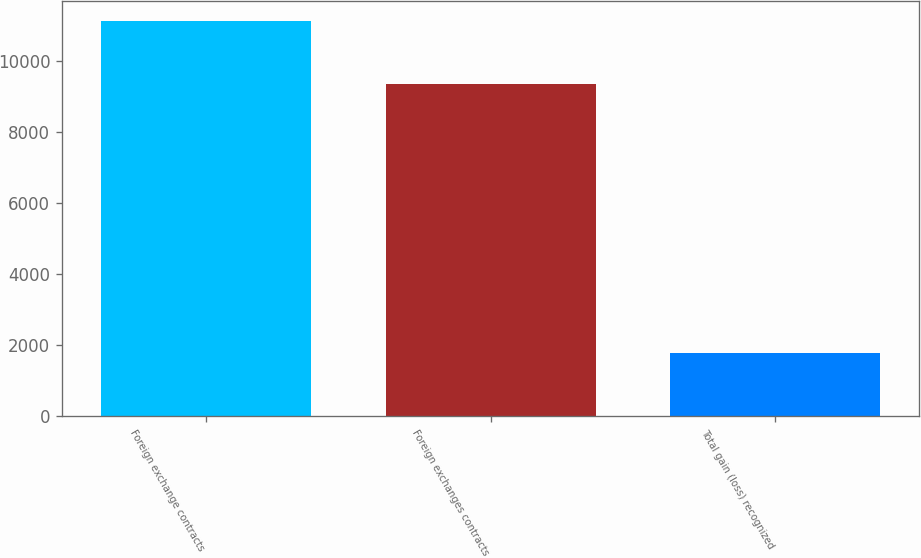Convert chart to OTSL. <chart><loc_0><loc_0><loc_500><loc_500><bar_chart><fcel>Foreign exchange contracts<fcel>Foreign exchanges contracts<fcel>Total gain (loss) recognized<nl><fcel>11135<fcel>9345<fcel>1790<nl></chart> 